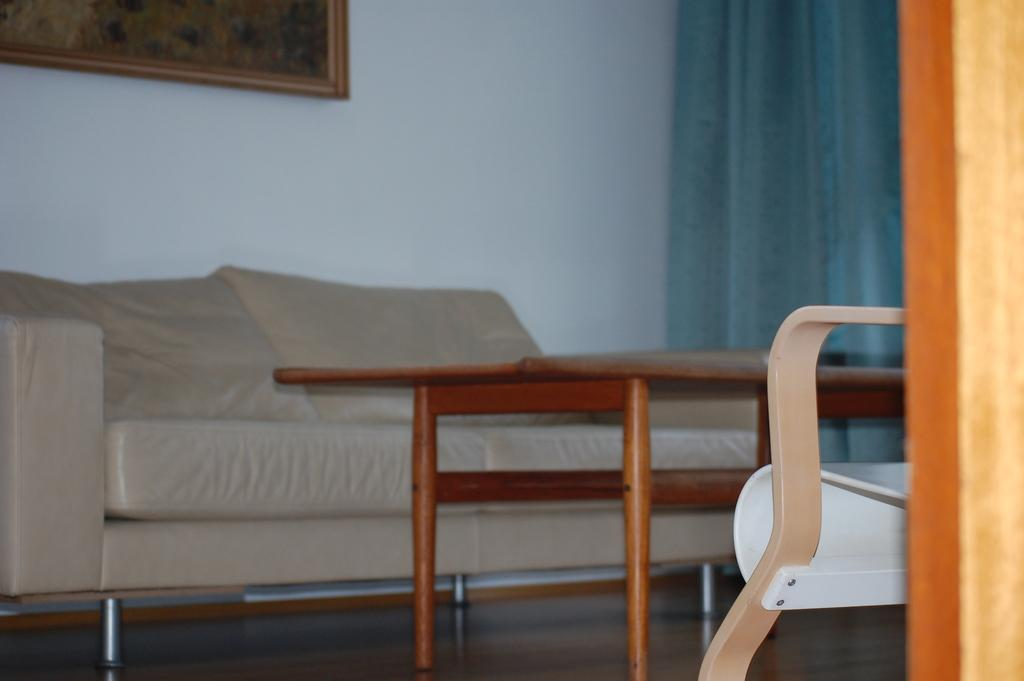What is the state of the room in the image? The room is closed. What type of furniture is present in the room? There is a sofa and a table in the room. Where are the curtains located in the image? The curtains are at the right corner of the picture. What is behind the sofa in the image? There is a wall behind the sofa. What is hanging on the wall in the image? There is a picture on the wall. What type of hair is visible on the table in the image? There is no hair visible on the table in the image. What kind of soup is being served on the sofa in the image? There is no soup present in the image; it features a sofa, a table, and other items mentioned in the conversation. 